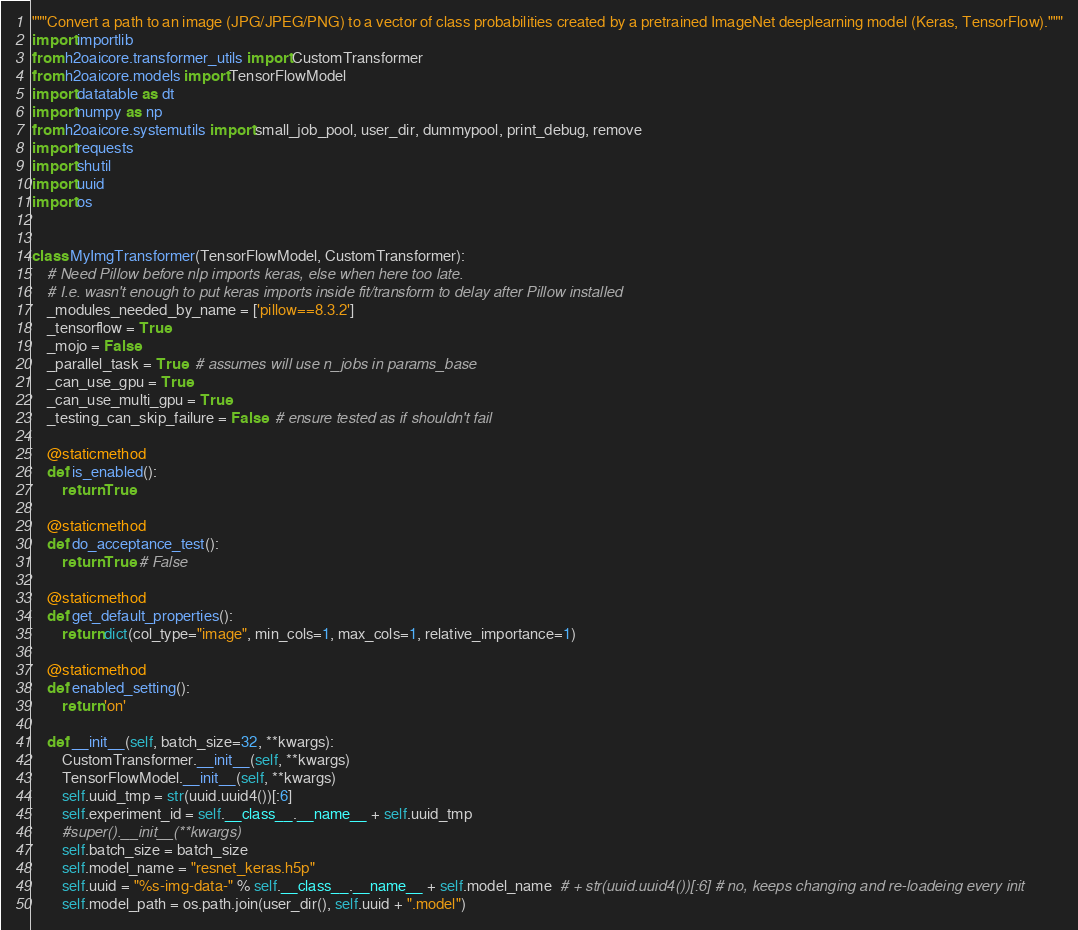Convert code to text. <code><loc_0><loc_0><loc_500><loc_500><_Python_>"""Convert a path to an image (JPG/JPEG/PNG) to a vector of class probabilities created by a pretrained ImageNet deeplearning model (Keras, TensorFlow)."""
import importlib
from h2oaicore.transformer_utils import CustomTransformer
from h2oaicore.models import TensorFlowModel
import datatable as dt
import numpy as np
from h2oaicore.systemutils import small_job_pool, user_dir, dummypool, print_debug, remove
import requests
import shutil
import uuid
import os


class MyImgTransformer(TensorFlowModel, CustomTransformer):
    # Need Pillow before nlp imports keras, else when here too late.
    # I.e. wasn't enough to put keras imports inside fit/transform to delay after Pillow installed
    _modules_needed_by_name = ['pillow==8.3.2']
    _tensorflow = True
    _mojo = False
    _parallel_task = True  # assumes will use n_jobs in params_base
    _can_use_gpu = True
    _can_use_multi_gpu = True
    _testing_can_skip_failure = False  # ensure tested as if shouldn't fail

    @staticmethod
    def is_enabled():
        return True

    @staticmethod
    def do_acceptance_test():
        return True # False

    @staticmethod
    def get_default_properties():
        return dict(col_type="image", min_cols=1, max_cols=1, relative_importance=1)

    @staticmethod
    def enabled_setting():
        return 'on'

    def __init__(self, batch_size=32, **kwargs):
        CustomTransformer.__init__(self, **kwargs)
        TensorFlowModel.__init__(self, **kwargs)
        self.uuid_tmp = str(uuid.uuid4())[:6]
        self.experiment_id = self.__class__.__name__ + self.uuid_tmp
        #super().__init__(**kwargs)
        self.batch_size = batch_size
        self.model_name = "resnet_keras.h5p"
        self.uuid = "%s-img-data-" % self.__class__.__name__ + self.model_name  # + str(uuid.uuid4())[:6] # no, keeps changing and re-loadeing every init
        self.model_path = os.path.join(user_dir(), self.uuid + ".model")</code> 